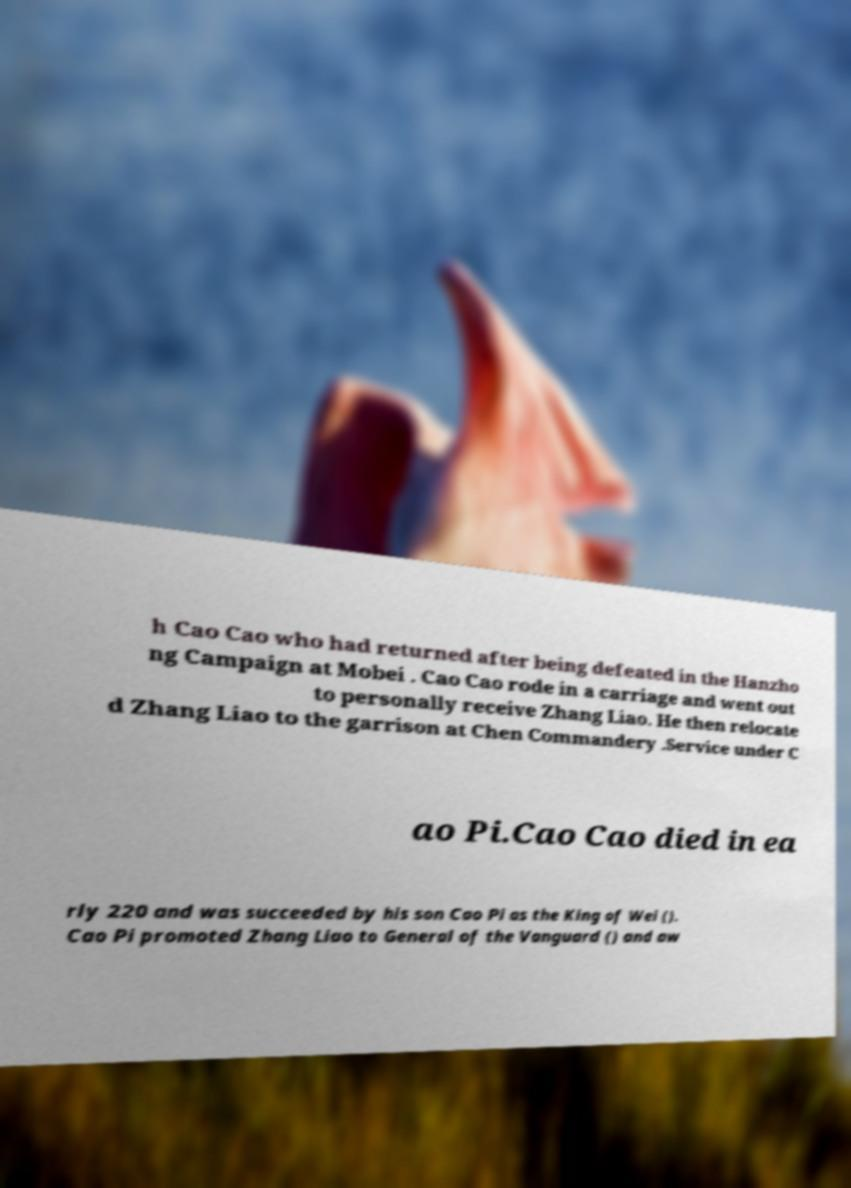Can you read and provide the text displayed in the image?This photo seems to have some interesting text. Can you extract and type it out for me? h Cao Cao who had returned after being defeated in the Hanzho ng Campaign at Mobei . Cao Cao rode in a carriage and went out to personally receive Zhang Liao. He then relocate d Zhang Liao to the garrison at Chen Commandery .Service under C ao Pi.Cao Cao died in ea rly 220 and was succeeded by his son Cao Pi as the King of Wei (). Cao Pi promoted Zhang Liao to General of the Vanguard () and aw 